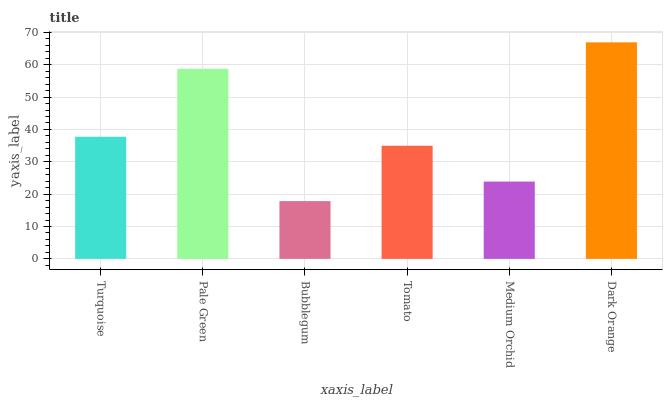Is Bubblegum the minimum?
Answer yes or no. Yes. Is Dark Orange the maximum?
Answer yes or no. Yes. Is Pale Green the minimum?
Answer yes or no. No. Is Pale Green the maximum?
Answer yes or no. No. Is Pale Green greater than Turquoise?
Answer yes or no. Yes. Is Turquoise less than Pale Green?
Answer yes or no. Yes. Is Turquoise greater than Pale Green?
Answer yes or no. No. Is Pale Green less than Turquoise?
Answer yes or no. No. Is Turquoise the high median?
Answer yes or no. Yes. Is Tomato the low median?
Answer yes or no. Yes. Is Pale Green the high median?
Answer yes or no. No. Is Dark Orange the low median?
Answer yes or no. No. 